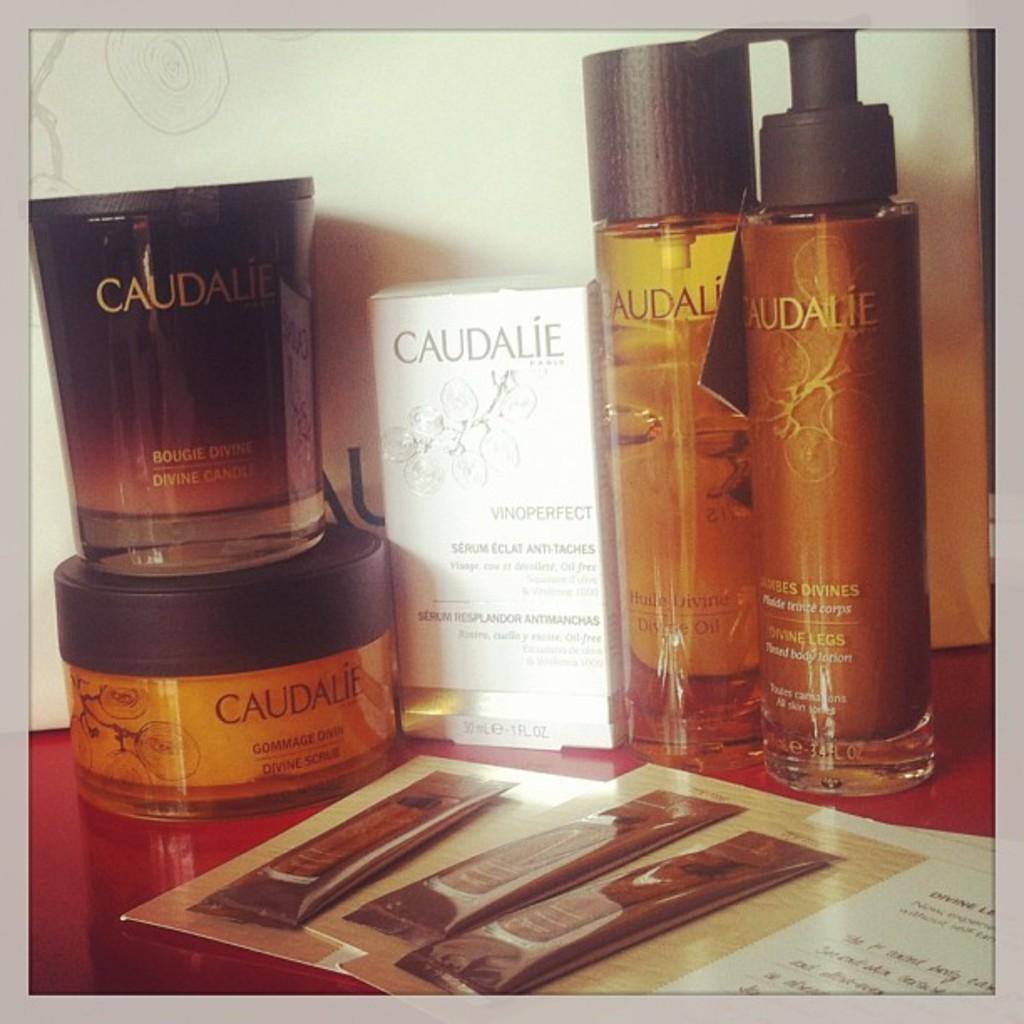Please provide a concise description of this image. In the picture we can see a face wash cream and some bottles of perfumes and some packets of cream are placed on the table. 